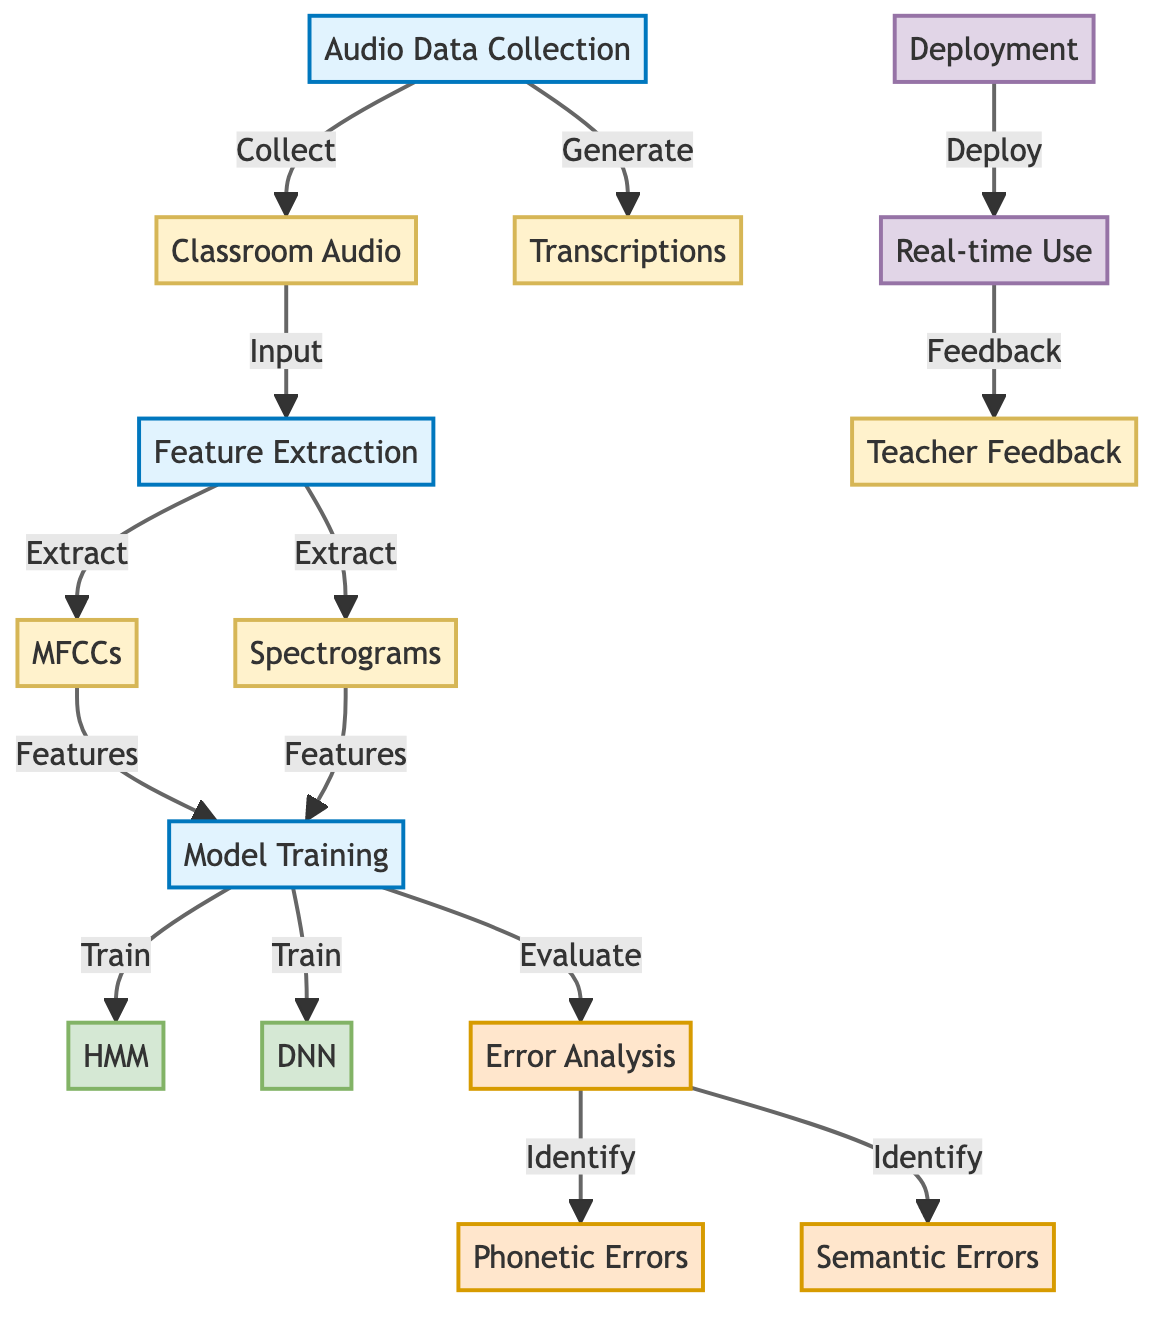What is the first process in the diagram? The diagram begins with the "Audio Data Collection" process, which is represented by the node labeled ADC. This node is the starting point in the flow of activities leading to Automatic Speech Recognition optimization.
Answer: Audio Data Collection How many types of features are extracted in the feature extraction step? In the feature extraction step represented by the node FE, two types of features are extracted: MFCCs and Spectrograms. Each feature is indicated as an output from the feature extraction process.
Answer: Two What are the models used for training in the model training phase? The model training phase MT involves training two different models, represented by the nodes HMM and DNN. These models are specifically used to optimize the Automatic Speech Recognition system.
Answer: HMM and DNN What type of errors are identified during the error analysis phase? The error analysis phase EA identifies two categories of errors: Phonetic Errors (PE) and Semantic Errors (SE). Both types are crucial for understanding and improving the ASR system's performance.
Answer: Phonetic Errors and Semantic Errors What is the final step of the diagram? The diagram concludes with the deployment phase, which is illustrated by the node DP leading to Real-time Use (RT). This step indicates the end goal, where the optimized ASR system is put into practical use within language classes.
Answer: Deployment 